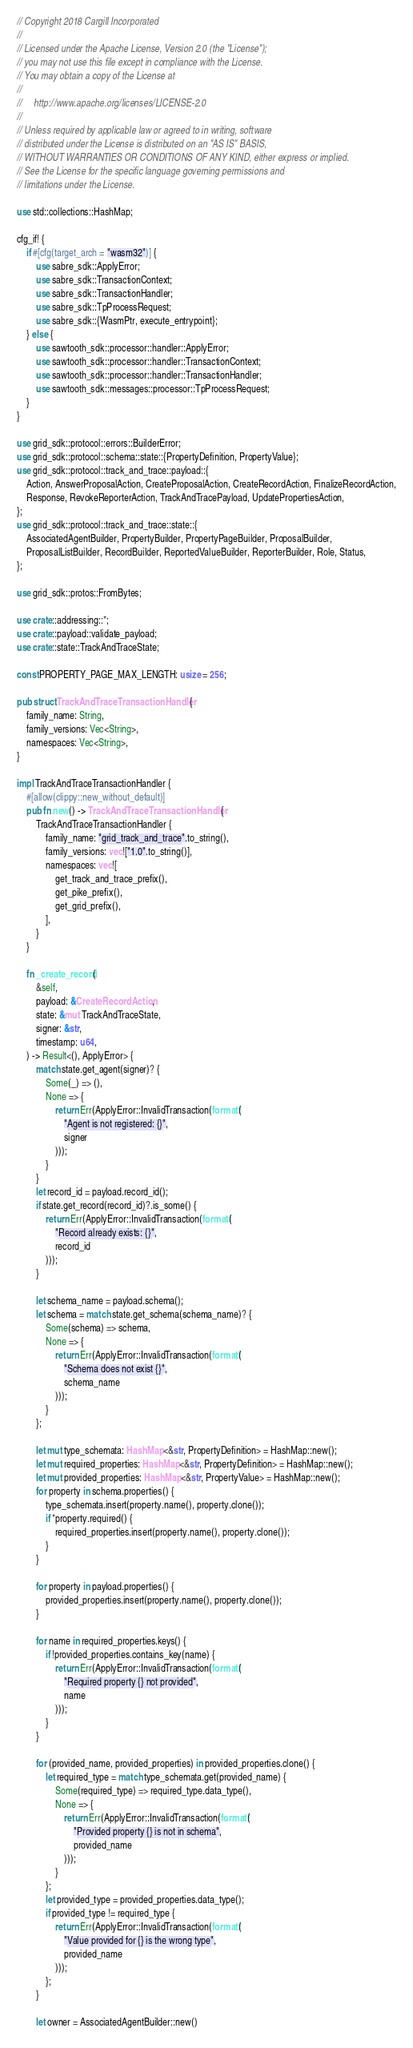<code> <loc_0><loc_0><loc_500><loc_500><_Rust_>// Copyright 2018 Cargill Incorporated
//
// Licensed under the Apache License, Version 2.0 (the "License");
// you may not use this file except in compliance with the License.
// You may obtain a copy of the License at
//
//     http://www.apache.org/licenses/LICENSE-2.0
//
// Unless required by applicable law or agreed to in writing, software
// distributed under the License is distributed on an "AS IS" BASIS,
// WITHOUT WARRANTIES OR CONDITIONS OF ANY KIND, either express or implied.
// See the License for the specific language governing permissions and
// limitations under the License.

use std::collections::HashMap;

cfg_if! {
    if #[cfg(target_arch = "wasm32")] {
        use sabre_sdk::ApplyError;
        use sabre_sdk::TransactionContext;
        use sabre_sdk::TransactionHandler;
        use sabre_sdk::TpProcessRequest;
        use sabre_sdk::{WasmPtr, execute_entrypoint};
    } else {
        use sawtooth_sdk::processor::handler::ApplyError;
        use sawtooth_sdk::processor::handler::TransactionContext;
        use sawtooth_sdk::processor::handler::TransactionHandler;
        use sawtooth_sdk::messages::processor::TpProcessRequest;
    }
}

use grid_sdk::protocol::errors::BuilderError;
use grid_sdk::protocol::schema::state::{PropertyDefinition, PropertyValue};
use grid_sdk::protocol::track_and_trace::payload::{
    Action, AnswerProposalAction, CreateProposalAction, CreateRecordAction, FinalizeRecordAction,
    Response, RevokeReporterAction, TrackAndTracePayload, UpdatePropertiesAction,
};
use grid_sdk::protocol::track_and_trace::state::{
    AssociatedAgentBuilder, PropertyBuilder, PropertyPageBuilder, ProposalBuilder,
    ProposalListBuilder, RecordBuilder, ReportedValueBuilder, ReporterBuilder, Role, Status,
};

use grid_sdk::protos::FromBytes;

use crate::addressing::*;
use crate::payload::validate_payload;
use crate::state::TrackAndTraceState;

const PROPERTY_PAGE_MAX_LENGTH: usize = 256;

pub struct TrackAndTraceTransactionHandler {
    family_name: String,
    family_versions: Vec<String>,
    namespaces: Vec<String>,
}

impl TrackAndTraceTransactionHandler {
    #[allow(clippy::new_without_default)]
    pub fn new() -> TrackAndTraceTransactionHandler {
        TrackAndTraceTransactionHandler {
            family_name: "grid_track_and_trace".to_string(),
            family_versions: vec!["1.0".to_string()],
            namespaces: vec![
                get_track_and_trace_prefix(),
                get_pike_prefix(),
                get_grid_prefix(),
            ],
        }
    }

    fn _create_record(
        &self,
        payload: &CreateRecordAction,
        state: &mut TrackAndTraceState,
        signer: &str,
        timestamp: u64,
    ) -> Result<(), ApplyError> {
        match state.get_agent(signer)? {
            Some(_) => (),
            None => {
                return Err(ApplyError::InvalidTransaction(format!(
                    "Agent is not registered: {}",
                    signer
                )));
            }
        }
        let record_id = payload.record_id();
        if state.get_record(record_id)?.is_some() {
            return Err(ApplyError::InvalidTransaction(format!(
                "Record already exists: {}",
                record_id
            )));
        }

        let schema_name = payload.schema();
        let schema = match state.get_schema(schema_name)? {
            Some(schema) => schema,
            None => {
                return Err(ApplyError::InvalidTransaction(format!(
                    "Schema does not exist {}",
                    schema_name
                )));
            }
        };

        let mut type_schemata: HashMap<&str, PropertyDefinition> = HashMap::new();
        let mut required_properties: HashMap<&str, PropertyDefinition> = HashMap::new();
        let mut provided_properties: HashMap<&str, PropertyValue> = HashMap::new();
        for property in schema.properties() {
            type_schemata.insert(property.name(), property.clone());
            if *property.required() {
                required_properties.insert(property.name(), property.clone());
            }
        }

        for property in payload.properties() {
            provided_properties.insert(property.name(), property.clone());
        }

        for name in required_properties.keys() {
            if !provided_properties.contains_key(name) {
                return Err(ApplyError::InvalidTransaction(format!(
                    "Required property {} not provided",
                    name
                )));
            }
        }

        for (provided_name, provided_properties) in provided_properties.clone() {
            let required_type = match type_schemata.get(provided_name) {
                Some(required_type) => required_type.data_type(),
                None => {
                    return Err(ApplyError::InvalidTransaction(format!(
                        "Provided property {} is not in schema",
                        provided_name
                    )));
                }
            };
            let provided_type = provided_properties.data_type();
            if provided_type != required_type {
                return Err(ApplyError::InvalidTransaction(format!(
                    "Value provided for {} is the wrong type",
                    provided_name
                )));
            };
        }

        let owner = AssociatedAgentBuilder::new()</code> 